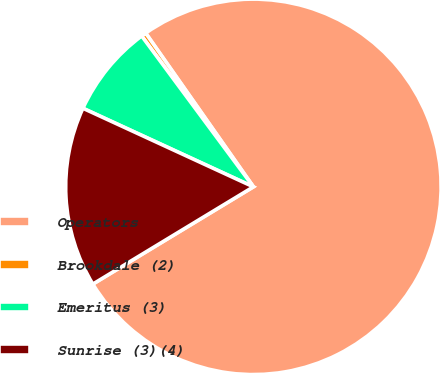Convert chart to OTSL. <chart><loc_0><loc_0><loc_500><loc_500><pie_chart><fcel>Operators<fcel>Brookdale (2)<fcel>Emeritus (3)<fcel>Sunrise (3)(4)<nl><fcel>76.06%<fcel>0.42%<fcel>7.98%<fcel>15.54%<nl></chart> 